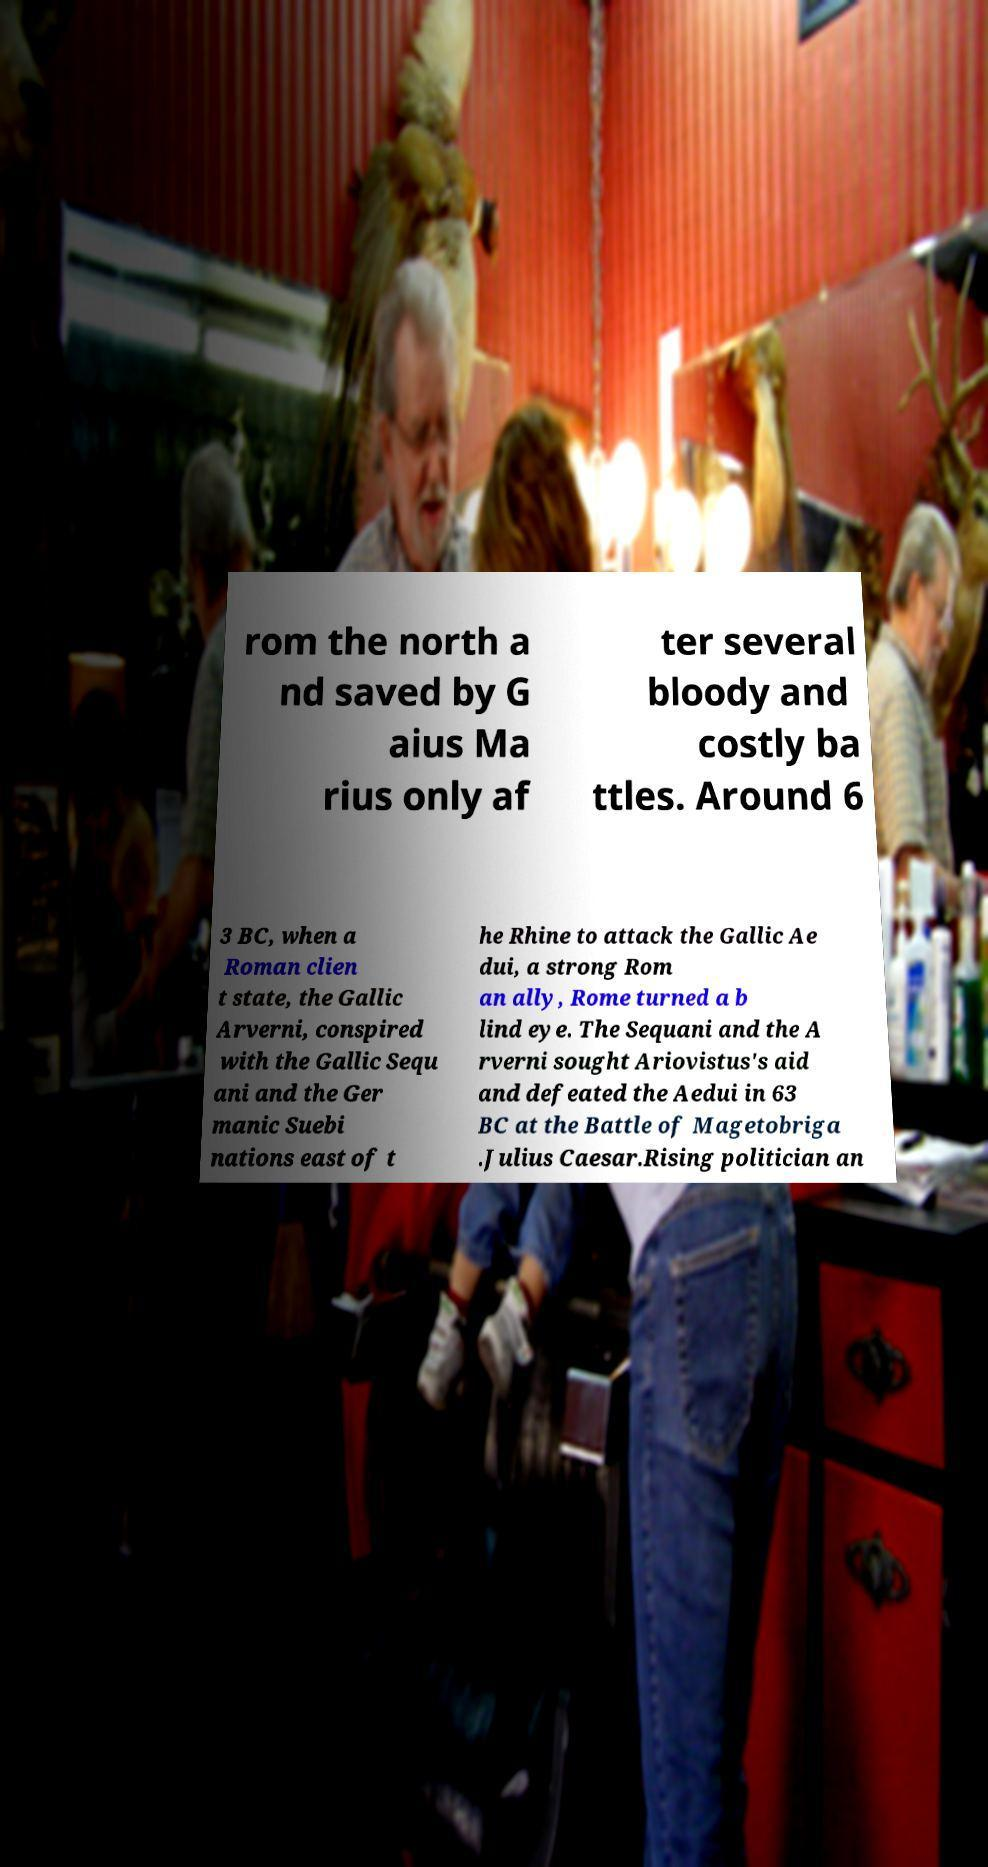Can you accurately transcribe the text from the provided image for me? rom the north a nd saved by G aius Ma rius only af ter several bloody and costly ba ttles. Around 6 3 BC, when a Roman clien t state, the Gallic Arverni, conspired with the Gallic Sequ ani and the Ger manic Suebi nations east of t he Rhine to attack the Gallic Ae dui, a strong Rom an ally, Rome turned a b lind eye. The Sequani and the A rverni sought Ariovistus's aid and defeated the Aedui in 63 BC at the Battle of Magetobriga .Julius Caesar.Rising politician an 